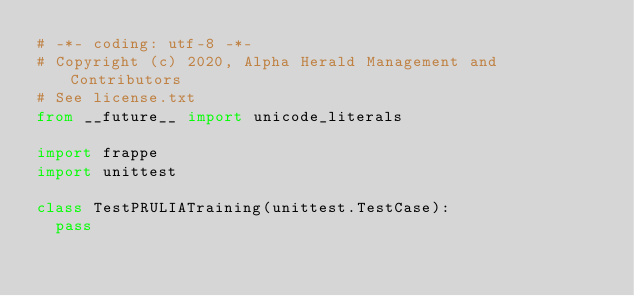Convert code to text. <code><loc_0><loc_0><loc_500><loc_500><_Python_># -*- coding: utf-8 -*-
# Copyright (c) 2020, Alpha Herald Management and Contributors
# See license.txt
from __future__ import unicode_literals

import frappe
import unittest

class TestPRULIATraining(unittest.TestCase):
	pass
</code> 